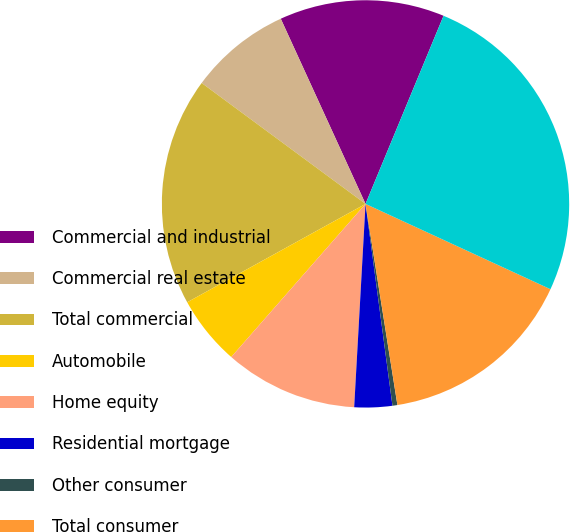<chart> <loc_0><loc_0><loc_500><loc_500><pie_chart><fcel>Commercial and industrial<fcel>Commercial real estate<fcel>Total commercial<fcel>Automobile<fcel>Home equity<fcel>Residential mortgage<fcel>Other consumer<fcel>Total consumer<fcel>Total loans/leases<nl><fcel>13.09%<fcel>8.05%<fcel>18.14%<fcel>5.52%<fcel>10.57%<fcel>3.0%<fcel>0.39%<fcel>15.62%<fcel>25.62%<nl></chart> 